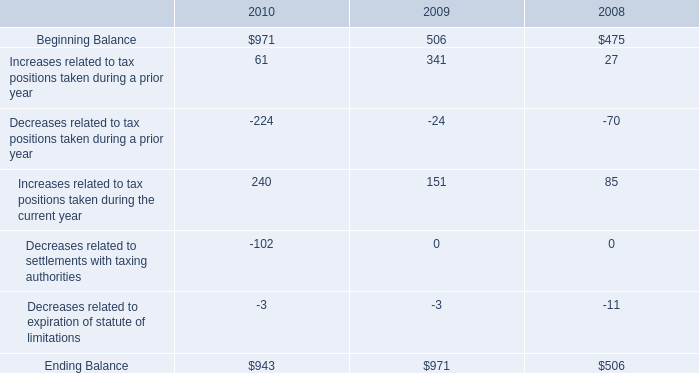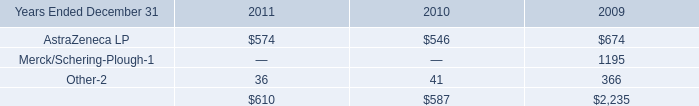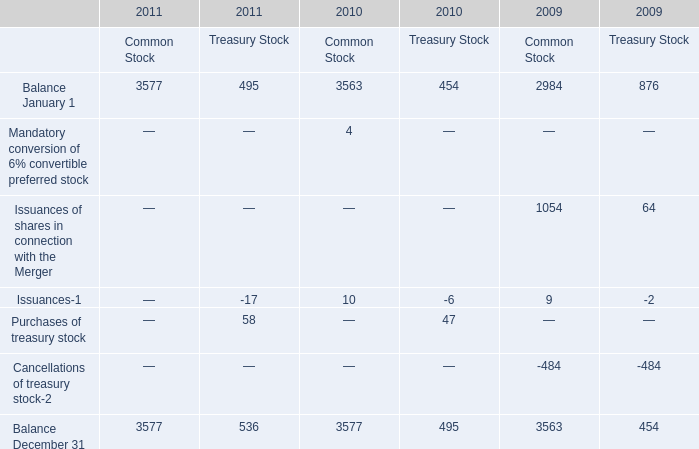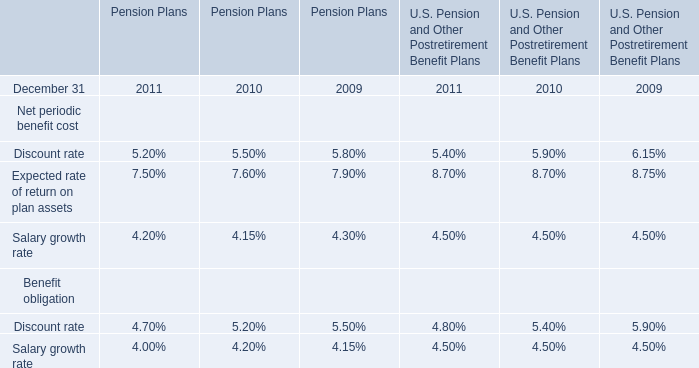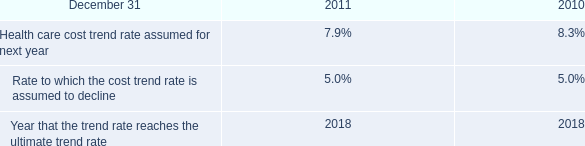What is the sum of the the Balance January 1 in the years where Issuances of shares in connection with the Merger for Common Stock greater than 1000? 
Computations: (2984 + 876)
Answer: 3860.0. 